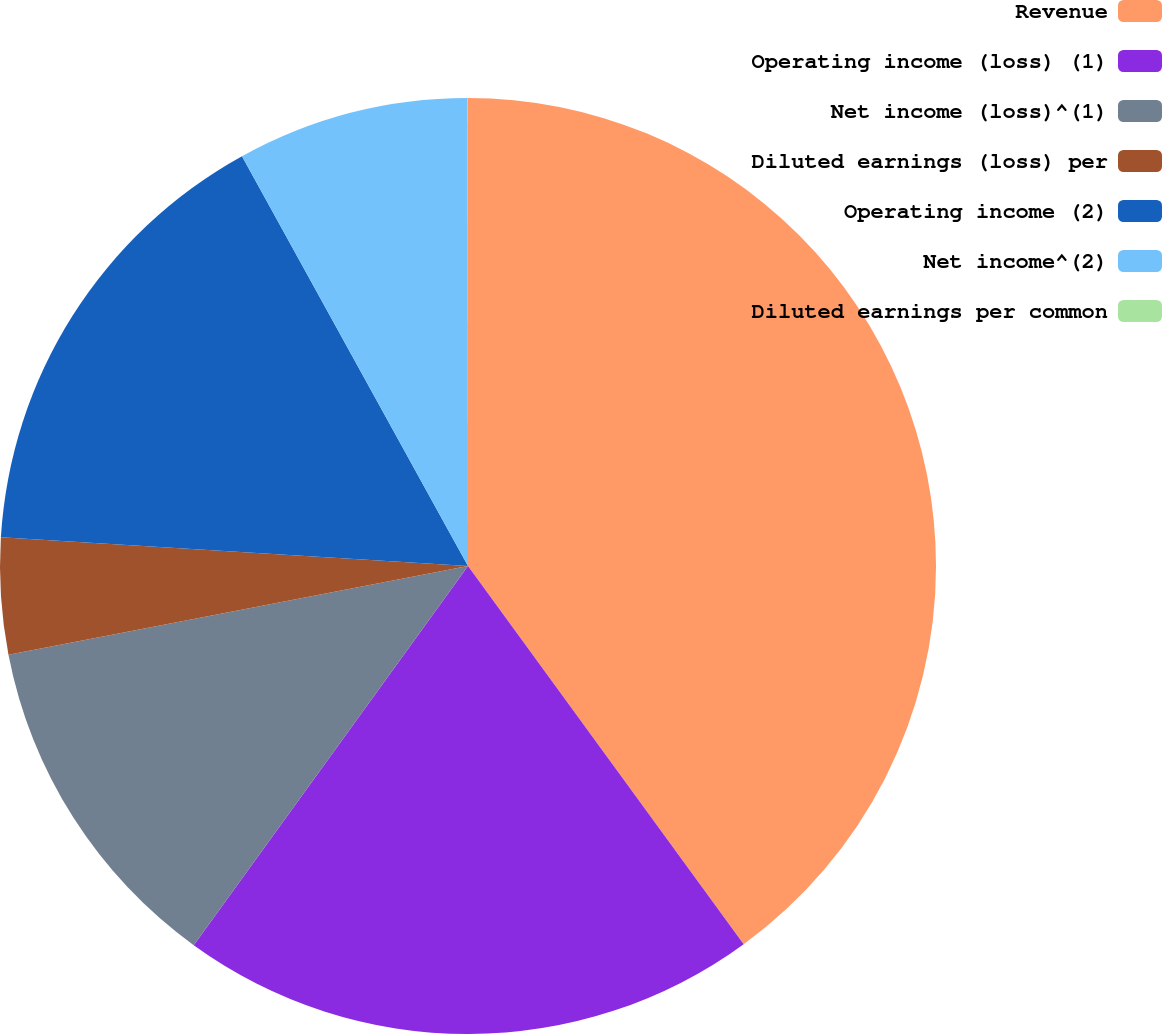Convert chart. <chart><loc_0><loc_0><loc_500><loc_500><pie_chart><fcel>Revenue<fcel>Operating income (loss) (1)<fcel>Net income (loss)^(1)<fcel>Diluted earnings (loss) per<fcel>Operating income (2)<fcel>Net income^(2)<fcel>Diluted earnings per common<nl><fcel>39.97%<fcel>19.99%<fcel>12.0%<fcel>4.01%<fcel>16.0%<fcel>8.01%<fcel>0.01%<nl></chart> 